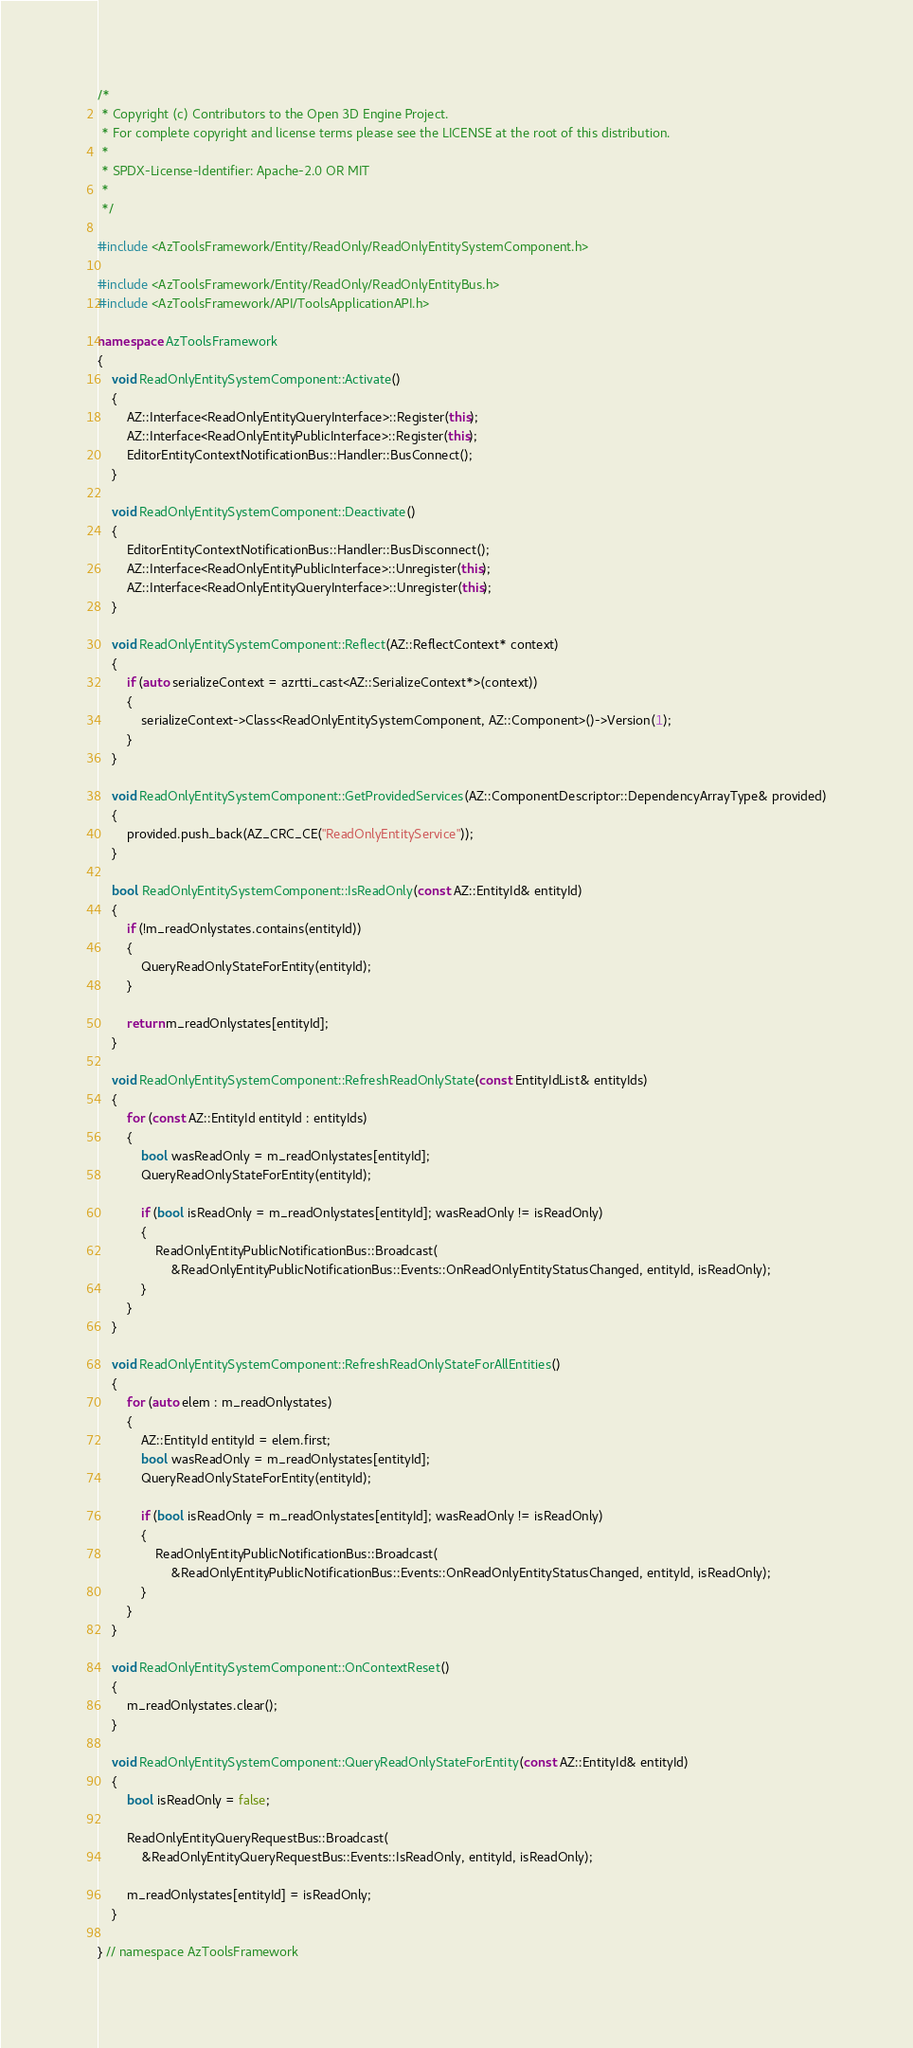Convert code to text. <code><loc_0><loc_0><loc_500><loc_500><_C++_>/*
 * Copyright (c) Contributors to the Open 3D Engine Project.
 * For complete copyright and license terms please see the LICENSE at the root of this distribution.
 *
 * SPDX-License-Identifier: Apache-2.0 OR MIT
 *
 */

#include <AzToolsFramework/Entity/ReadOnly/ReadOnlyEntitySystemComponent.h>

#include <AzToolsFramework/Entity/ReadOnly/ReadOnlyEntityBus.h>
#include <AzToolsFramework/API/ToolsApplicationAPI.h>

namespace AzToolsFramework
{
    void ReadOnlyEntitySystemComponent::Activate()
    {
        AZ::Interface<ReadOnlyEntityQueryInterface>::Register(this);
        AZ::Interface<ReadOnlyEntityPublicInterface>::Register(this);
        EditorEntityContextNotificationBus::Handler::BusConnect();
    }

    void ReadOnlyEntitySystemComponent::Deactivate()
    {
        EditorEntityContextNotificationBus::Handler::BusDisconnect();
        AZ::Interface<ReadOnlyEntityPublicInterface>::Unregister(this);
        AZ::Interface<ReadOnlyEntityQueryInterface>::Unregister(this);
    }

    void ReadOnlyEntitySystemComponent::Reflect(AZ::ReflectContext* context)
    {
        if (auto serializeContext = azrtti_cast<AZ::SerializeContext*>(context))
        {
            serializeContext->Class<ReadOnlyEntitySystemComponent, AZ::Component>()->Version(1);
        }
    }

    void ReadOnlyEntitySystemComponent::GetProvidedServices(AZ::ComponentDescriptor::DependencyArrayType& provided)
    {
        provided.push_back(AZ_CRC_CE("ReadOnlyEntityService"));
    }

    bool ReadOnlyEntitySystemComponent::IsReadOnly(const AZ::EntityId& entityId)
    {
        if (!m_readOnlystates.contains(entityId))
        {
            QueryReadOnlyStateForEntity(entityId);
        }

        return m_readOnlystates[entityId];
    }

    void ReadOnlyEntitySystemComponent::RefreshReadOnlyState(const EntityIdList& entityIds)
    {
        for (const AZ::EntityId entityId : entityIds)
        {
            bool wasReadOnly = m_readOnlystates[entityId];
            QueryReadOnlyStateForEntity(entityId);

            if (bool isReadOnly = m_readOnlystates[entityId]; wasReadOnly != isReadOnly)
            {
                ReadOnlyEntityPublicNotificationBus::Broadcast(
                    &ReadOnlyEntityPublicNotificationBus::Events::OnReadOnlyEntityStatusChanged, entityId, isReadOnly);
            }
        }
    }

    void ReadOnlyEntitySystemComponent::RefreshReadOnlyStateForAllEntities()
    {
        for (auto elem : m_readOnlystates)
        {
            AZ::EntityId entityId = elem.first;
            bool wasReadOnly = m_readOnlystates[entityId];
            QueryReadOnlyStateForEntity(entityId);

            if (bool isReadOnly = m_readOnlystates[entityId]; wasReadOnly != isReadOnly)
            {
                ReadOnlyEntityPublicNotificationBus::Broadcast(
                    &ReadOnlyEntityPublicNotificationBus::Events::OnReadOnlyEntityStatusChanged, entityId, isReadOnly);
            }
        }
    }

    void ReadOnlyEntitySystemComponent::OnContextReset()
    {
        m_readOnlystates.clear();
    }

    void ReadOnlyEntitySystemComponent::QueryReadOnlyStateForEntity(const AZ::EntityId& entityId)
    {
        bool isReadOnly = false;

        ReadOnlyEntityQueryRequestBus::Broadcast(
            &ReadOnlyEntityQueryRequestBus::Events::IsReadOnly, entityId, isReadOnly);

        m_readOnlystates[entityId] = isReadOnly;
    }

} // namespace AzToolsFramework
</code> 